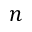Convert formula to latex. <formula><loc_0><loc_0><loc_500><loc_500>n</formula> 